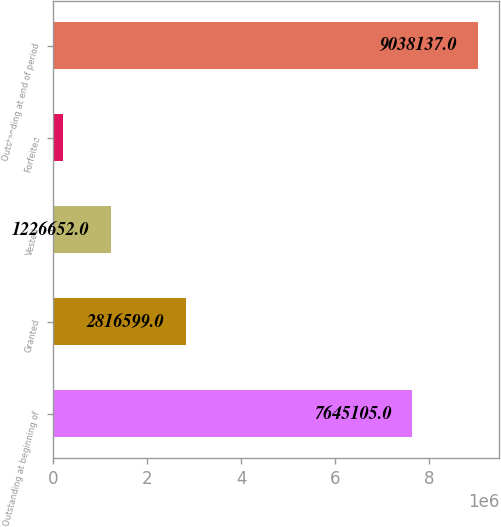Convert chart. <chart><loc_0><loc_0><loc_500><loc_500><bar_chart><fcel>Outstanding at beginning of<fcel>Granted<fcel>Vested<fcel>Forfeited<fcel>Outstanding at end of period<nl><fcel>7.6451e+06<fcel>2.8166e+06<fcel>1.22665e+06<fcel>196915<fcel>9.03814e+06<nl></chart> 